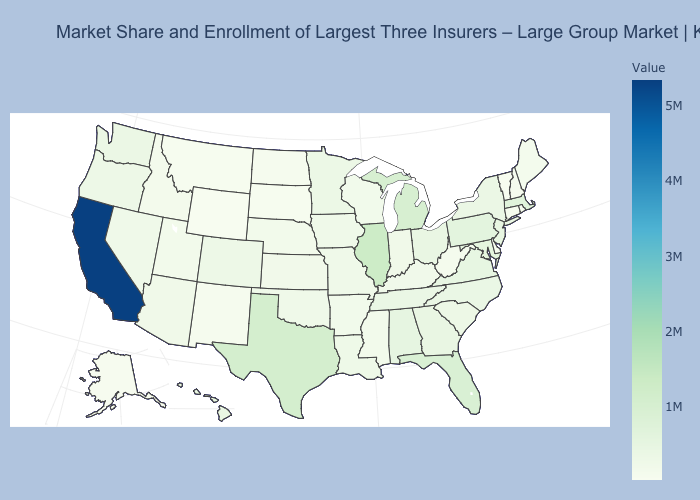Is the legend a continuous bar?
Answer briefly. Yes. Does California have the highest value in the USA?
Be succinct. Yes. Does North Carolina have a lower value than California?
Give a very brief answer. Yes. Among the states that border Georgia , does South Carolina have the lowest value?
Give a very brief answer. Yes. 